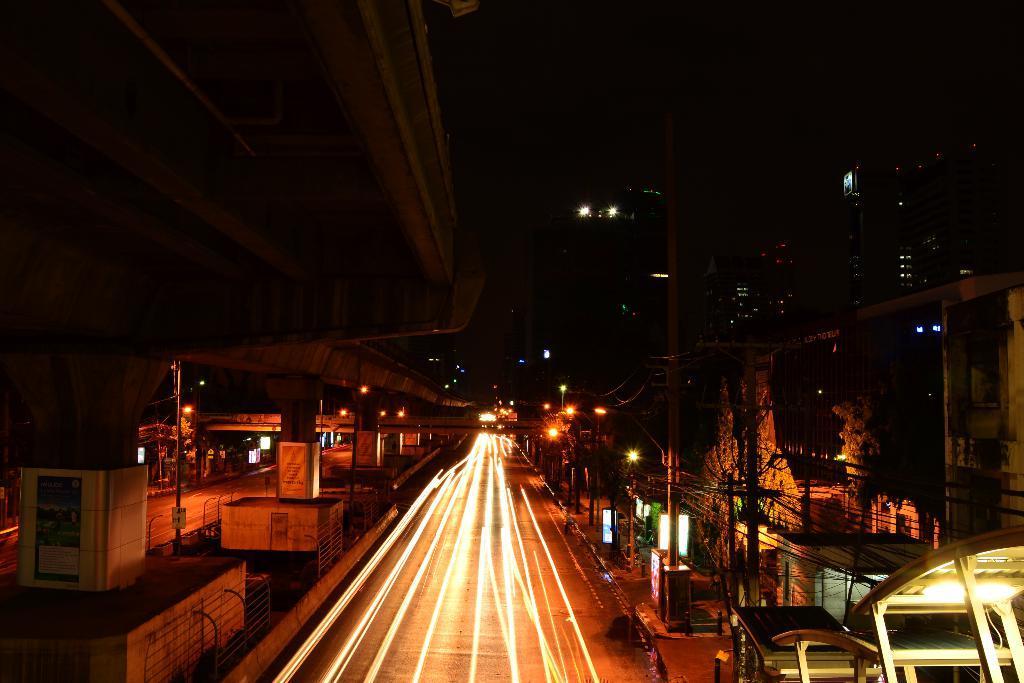Describe this image in one or two sentences. This picture is clicked outside the city. At the bottom of the picture, we see the road. On the right side, we see trees, electric poles, wires and buildings. On the left side, we see transformers, trees and street lights. In the background, we see a bridge, street lights and buildings. We even see vehicles moving on the road. In the background, it is black in color. This picture is clicked in the dark. 